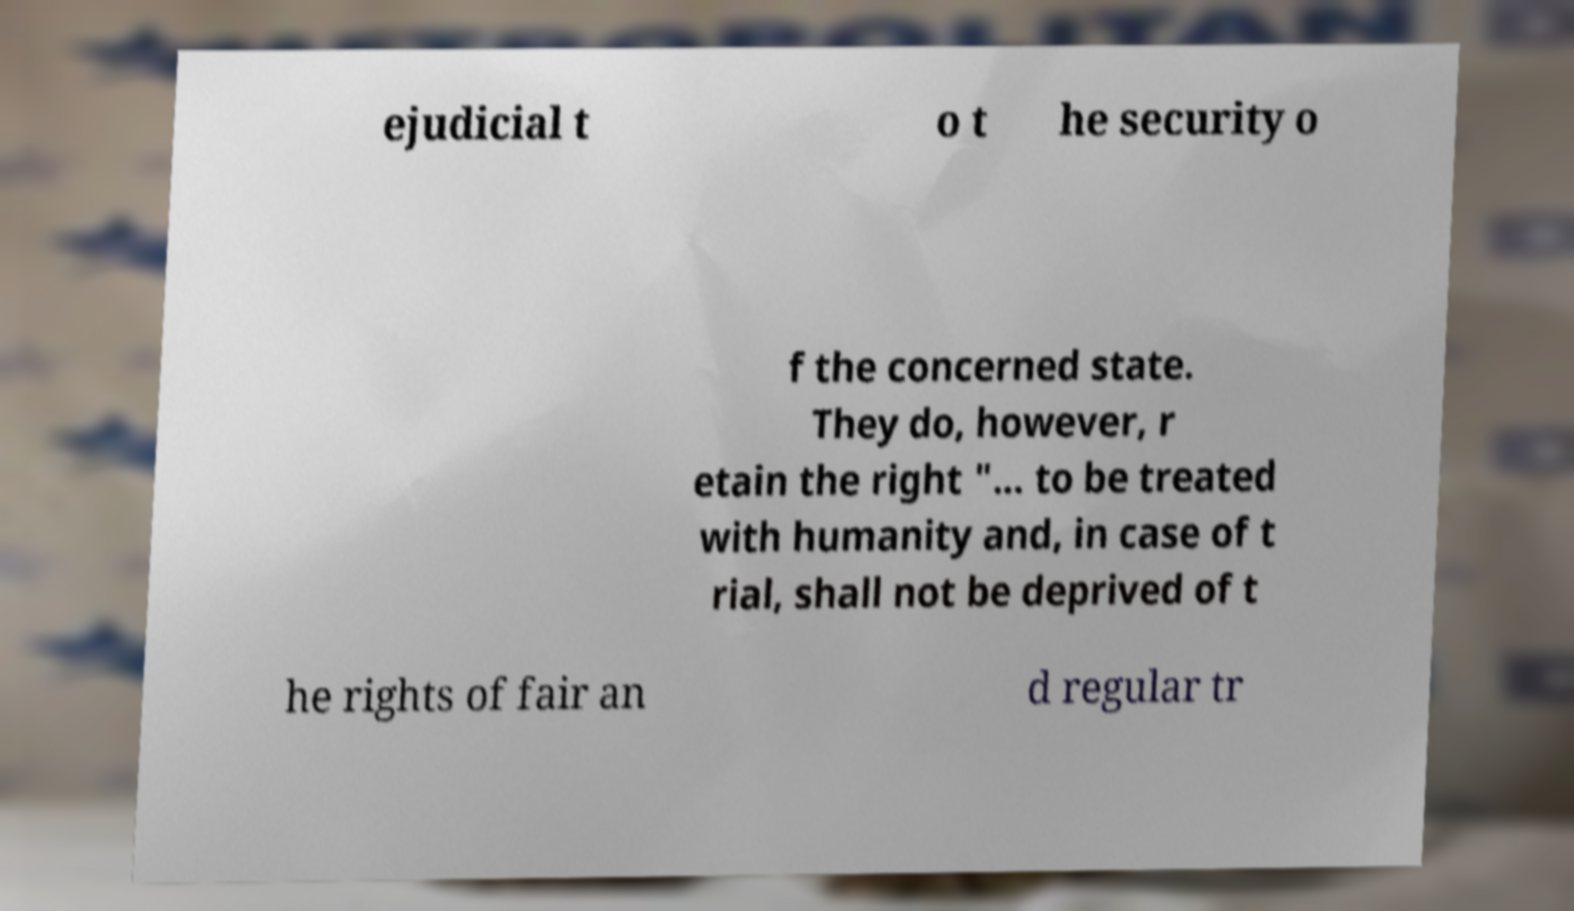Could you extract and type out the text from this image? ejudicial t o t he security o f the concerned state. They do, however, r etain the right "... to be treated with humanity and, in case of t rial, shall not be deprived of t he rights of fair an d regular tr 